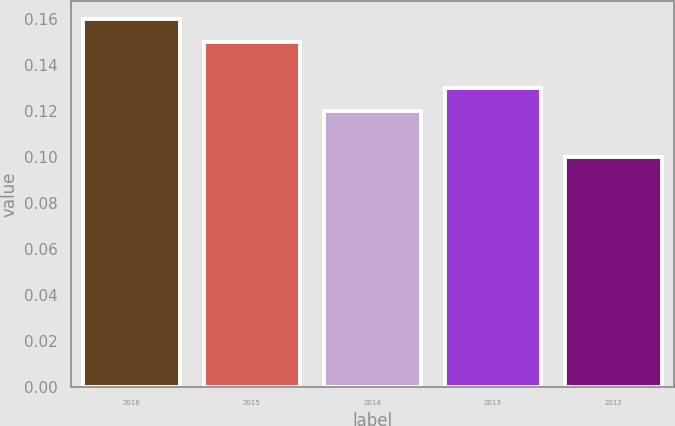Convert chart to OTSL. <chart><loc_0><loc_0><loc_500><loc_500><bar_chart><fcel>2016<fcel>2015<fcel>2014<fcel>2013<fcel>2012<nl><fcel>0.16<fcel>0.15<fcel>0.12<fcel>0.13<fcel>0.1<nl></chart> 